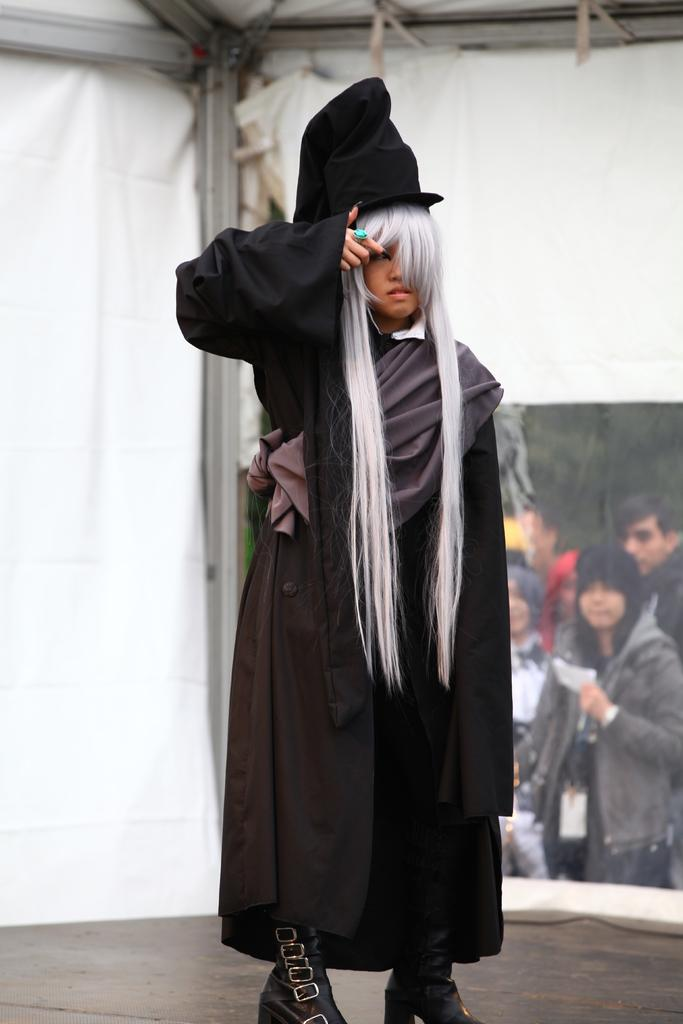What is happening in the foreground of the image? There is a person standing on the stage in the foreground. What is the person wearing? The person is wearing a costume. What can be seen in the background of the image? There is a group of people, trees, and a tent in the background. Can you describe the lighting in the image? The image is likely taken during the day, as there is sufficient natural light. What type of hammer is being used to fix the hole in the tent in the image? There is no hammer or hole present in the image; it only features a person on stage, a group of people, trees, and a tent in the background. 